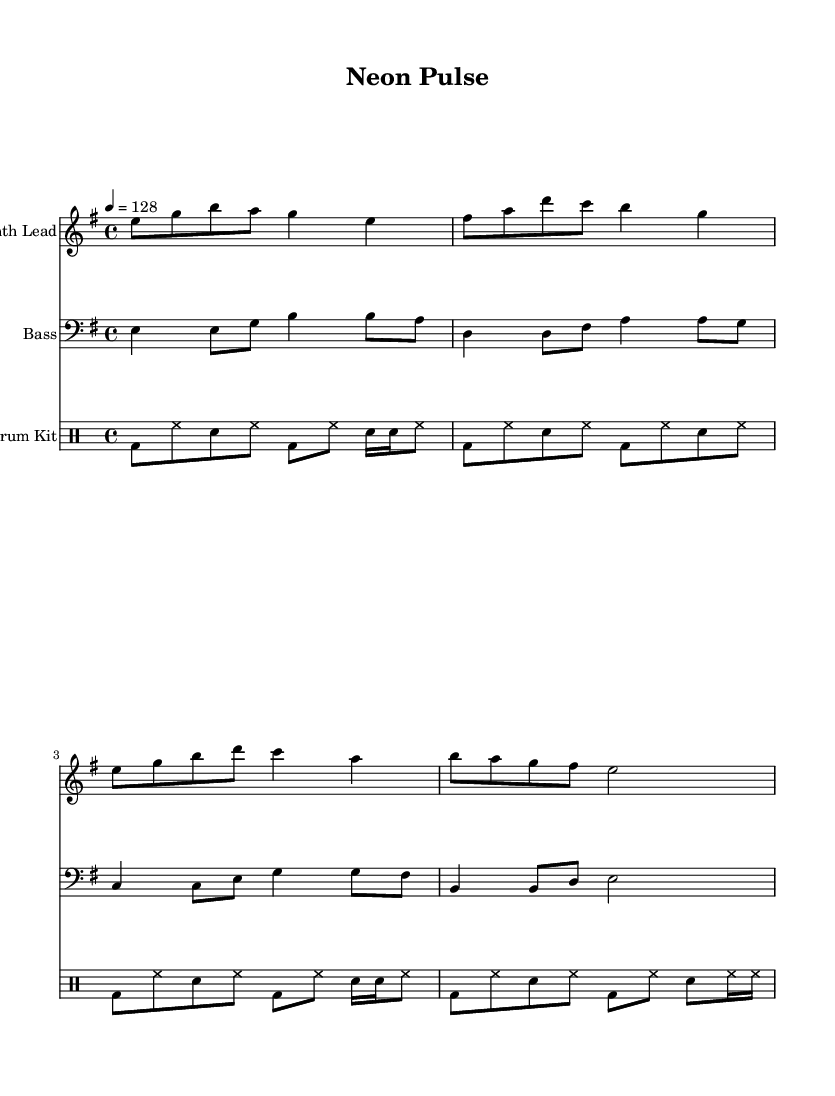What is the key signature of this music? The key signature is E minor, which has one sharp (F#) and indicates the tonality of the piece.
Answer: E minor What is the time signature of this music? The time signature is 4/4, which means there are four beats in a measure and a quarter note gets one beat.
Answer: 4/4 What is the tempo marking for this piece? The tempo marking is 4 equals 128, meaning that there are 128 beats per minute. This indicates a moderate to fast pace suitable for contemporary dance music.
Answer: 128 What instruments are featured in this score? The score features a Synth Lead, Bass, and a Drum Kit, indicated by the respective staff labels for each instrument.
Answer: Synth Lead, Bass, Drum Kit How many beats are in the first measure of the Synth Lead? The first measure of the Synth Lead contains eight eighth notes (eighth-note subdivisions), summing to four quarter-note beats, matching the time signature.
Answer: 4 Which rhythmic element is primarily used in the drum part? The drum part utilizes a combination of bass drum and snare patterns, featuring a steady bass drum on downbeats, and snare hits on upbeats, common in electronic dance music.
Answer: Bass drum and snare patterns What is the interval between the first and second notes of the Synth Lead? The first note is E, and the second note is G, which spans a minor third interval in the E minor scale, characteristic of the piece's harmonic structure.
Answer: Minor third 